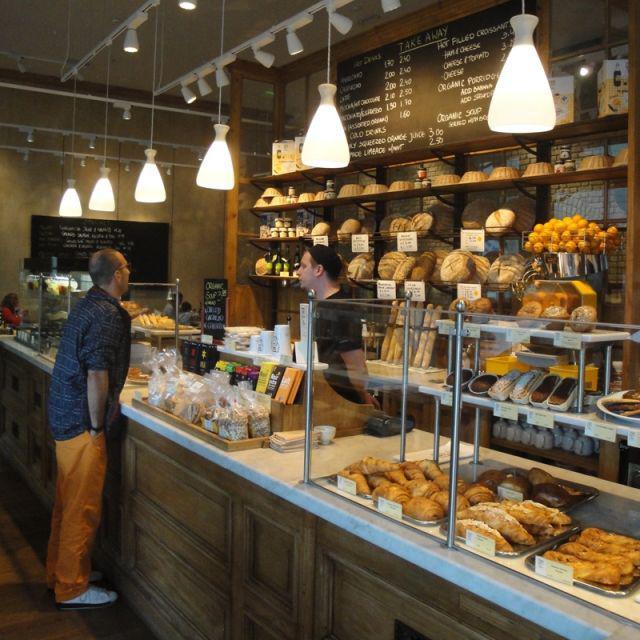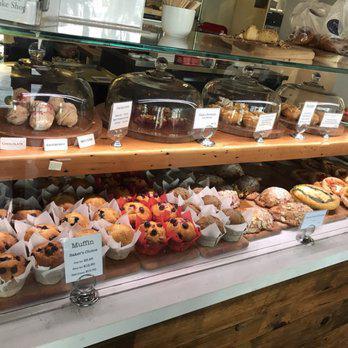The first image is the image on the left, the second image is the image on the right. For the images displayed, is the sentence "The floor can be seen in one of the images." factually correct? Answer yes or no. Yes. 